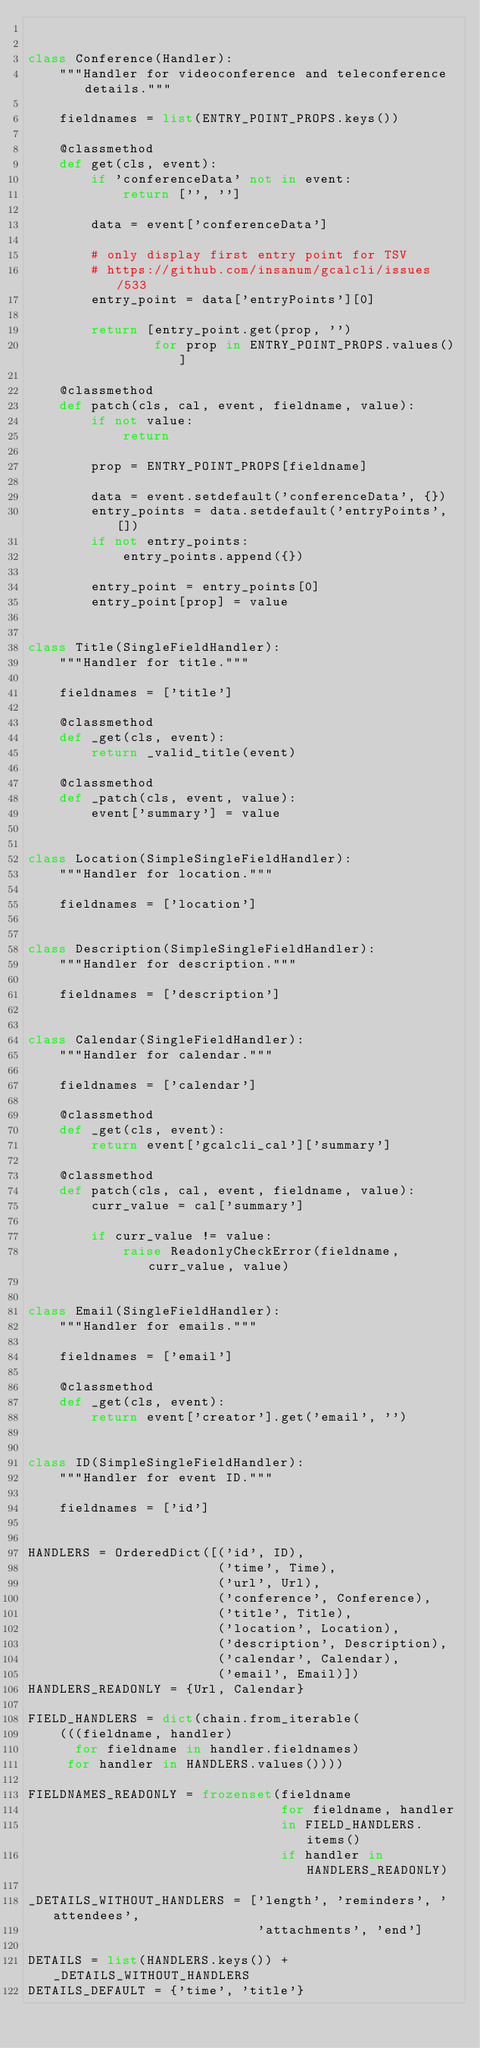Convert code to text. <code><loc_0><loc_0><loc_500><loc_500><_Python_>

class Conference(Handler):
    """Handler for videoconference and teleconference details."""

    fieldnames = list(ENTRY_POINT_PROPS.keys())

    @classmethod
    def get(cls, event):
        if 'conferenceData' not in event:
            return ['', '']

        data = event['conferenceData']

        # only display first entry point for TSV
        # https://github.com/insanum/gcalcli/issues/533
        entry_point = data['entryPoints'][0]

        return [entry_point.get(prop, '')
                for prop in ENTRY_POINT_PROPS.values()]

    @classmethod
    def patch(cls, cal, event, fieldname, value):
        if not value:
            return

        prop = ENTRY_POINT_PROPS[fieldname]

        data = event.setdefault('conferenceData', {})
        entry_points = data.setdefault('entryPoints', [])
        if not entry_points:
            entry_points.append({})

        entry_point = entry_points[0]
        entry_point[prop] = value


class Title(SingleFieldHandler):
    """Handler for title."""

    fieldnames = ['title']

    @classmethod
    def _get(cls, event):
        return _valid_title(event)

    @classmethod
    def _patch(cls, event, value):
        event['summary'] = value


class Location(SimpleSingleFieldHandler):
    """Handler for location."""

    fieldnames = ['location']


class Description(SimpleSingleFieldHandler):
    """Handler for description."""

    fieldnames = ['description']


class Calendar(SingleFieldHandler):
    """Handler for calendar."""

    fieldnames = ['calendar']

    @classmethod
    def _get(cls, event):
        return event['gcalcli_cal']['summary']

    @classmethod
    def patch(cls, cal, event, fieldname, value):
        curr_value = cal['summary']

        if curr_value != value:
            raise ReadonlyCheckError(fieldname, curr_value, value)


class Email(SingleFieldHandler):
    """Handler for emails."""

    fieldnames = ['email']

    @classmethod
    def _get(cls, event):
        return event['creator'].get('email', '')


class ID(SimpleSingleFieldHandler):
    """Handler for event ID."""

    fieldnames = ['id']


HANDLERS = OrderedDict([('id', ID),
                        ('time', Time),
                        ('url', Url),
                        ('conference', Conference),
                        ('title', Title),
                        ('location', Location),
                        ('description', Description),
                        ('calendar', Calendar),
                        ('email', Email)])
HANDLERS_READONLY = {Url, Calendar}

FIELD_HANDLERS = dict(chain.from_iterable(
    (((fieldname, handler)
      for fieldname in handler.fieldnames)
     for handler in HANDLERS.values())))

FIELDNAMES_READONLY = frozenset(fieldname
                                for fieldname, handler
                                in FIELD_HANDLERS.items()
                                if handler in HANDLERS_READONLY)

_DETAILS_WITHOUT_HANDLERS = ['length', 'reminders', 'attendees',
                             'attachments', 'end']

DETAILS = list(HANDLERS.keys()) + _DETAILS_WITHOUT_HANDLERS
DETAILS_DEFAULT = {'time', 'title'}
</code> 